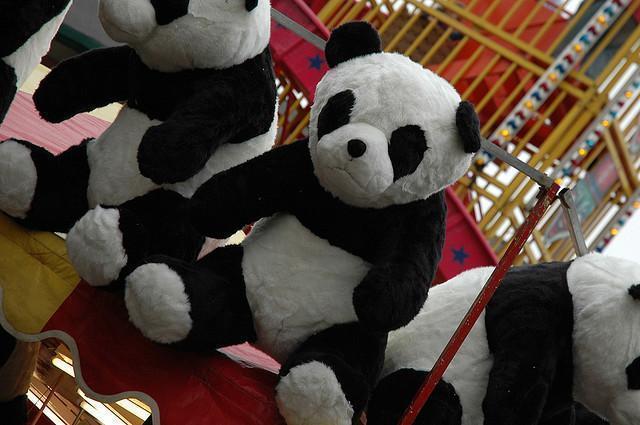This animal is a symbol of what nation?
Select the accurate answer and provide explanation: 'Answer: answer
Rationale: rationale.'
Options: Ukraine, china, scotland, tanzania. Answer: china.
Rationale: The panda is from china. 